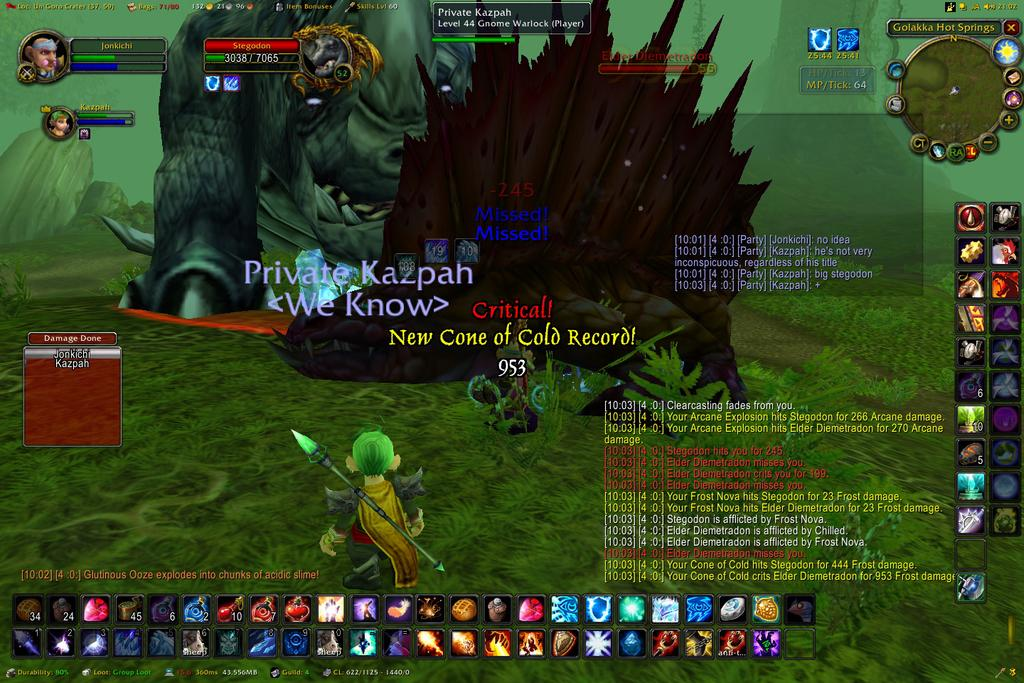What type of images are present in the image? The image contains cartoon images. Are there any words or phrases in the image? Yes, there are texts in the image. What other visual elements can be found in the image? There are icons in the image. What is the color of the background in the image? The background color is green. What type of jelly can be seen on the canvas in the image? There is no canvas or jelly present in the image; it contains cartoon images, texts, and icons on a green background. 